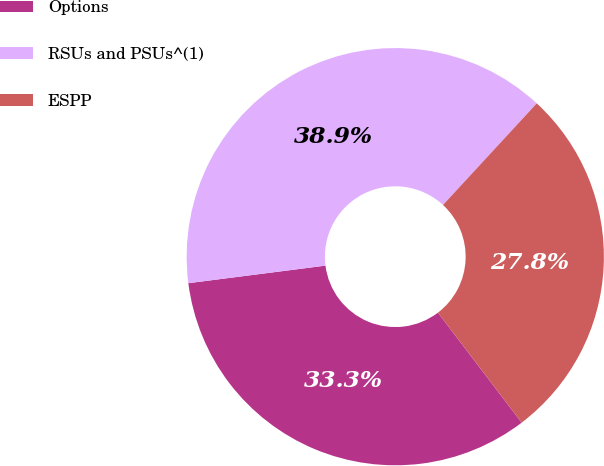Convert chart. <chart><loc_0><loc_0><loc_500><loc_500><pie_chart><fcel>Options<fcel>RSUs and PSUs^(1)<fcel>ESPP<nl><fcel>33.33%<fcel>38.89%<fcel>27.78%<nl></chart> 